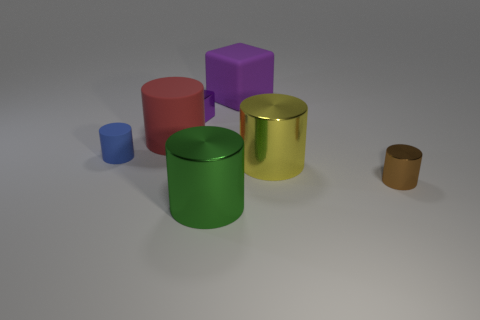Does the cube to the right of the purple shiny cube have the same color as the metallic cube?
Provide a short and direct response. Yes. Is there a big matte cylinder behind the large shiny object that is behind the small metal cylinder?
Keep it short and to the point. Yes. There is a large cylinder that is left of the large yellow cylinder and behind the small brown object; what material is it?
Offer a very short reply. Rubber. What is the shape of the purple object that is the same material as the small blue cylinder?
Provide a succinct answer. Cube. Is there any other thing that is the same shape as the big yellow metallic object?
Provide a short and direct response. Yes. Are the big object right of the big purple thing and the green cylinder made of the same material?
Keep it short and to the point. Yes. There is a big thing behind the big red matte object; what is its material?
Ensure brevity in your answer.  Rubber. What is the size of the purple object behind the cube that is in front of the purple matte object?
Provide a short and direct response. Large. How many purple rubber things have the same size as the red cylinder?
Offer a very short reply. 1. There is a cylinder in front of the small brown cylinder; does it have the same color as the big cylinder that is behind the yellow metal thing?
Keep it short and to the point. No. 